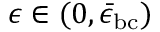<formula> <loc_0><loc_0><loc_500><loc_500>\epsilon \in ( 0 , \bar { \epsilon } _ { b c } )</formula> 